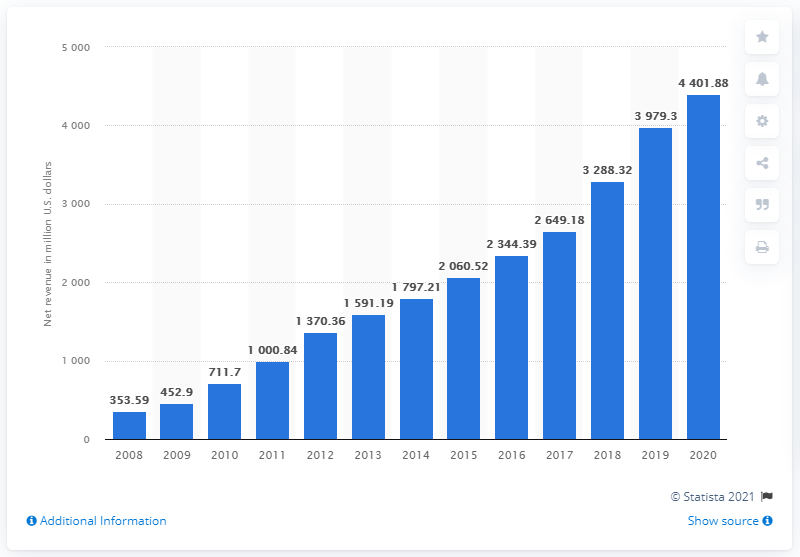Outline some significant characteristics in this image. In the financial year of 2020, lululemon generated a net revenue of 4401.88. 